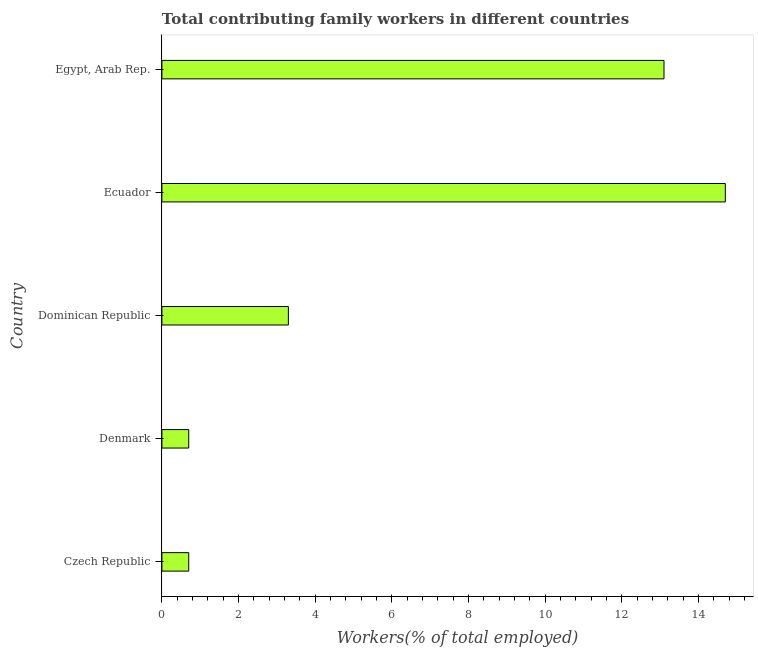Does the graph contain any zero values?
Keep it short and to the point. No. Does the graph contain grids?
Offer a terse response. No. What is the title of the graph?
Make the answer very short. Total contributing family workers in different countries. What is the label or title of the X-axis?
Make the answer very short. Workers(% of total employed). What is the contributing family workers in Dominican Republic?
Your answer should be very brief. 3.3. Across all countries, what is the maximum contributing family workers?
Offer a terse response. 14.7. Across all countries, what is the minimum contributing family workers?
Provide a succinct answer. 0.7. In which country was the contributing family workers maximum?
Offer a very short reply. Ecuador. In which country was the contributing family workers minimum?
Offer a very short reply. Czech Republic. What is the sum of the contributing family workers?
Offer a terse response. 32.5. What is the average contributing family workers per country?
Make the answer very short. 6.5. What is the median contributing family workers?
Give a very brief answer. 3.3. What is the ratio of the contributing family workers in Dominican Republic to that in Ecuador?
Offer a very short reply. 0.22. What is the difference between the highest and the second highest contributing family workers?
Your answer should be very brief. 1.6. In how many countries, is the contributing family workers greater than the average contributing family workers taken over all countries?
Ensure brevity in your answer.  2. How many bars are there?
Your response must be concise. 5. Are all the bars in the graph horizontal?
Provide a short and direct response. Yes. What is the difference between two consecutive major ticks on the X-axis?
Ensure brevity in your answer.  2. What is the Workers(% of total employed) in Czech Republic?
Offer a terse response. 0.7. What is the Workers(% of total employed) in Denmark?
Your answer should be very brief. 0.7. What is the Workers(% of total employed) in Dominican Republic?
Offer a very short reply. 3.3. What is the Workers(% of total employed) of Ecuador?
Ensure brevity in your answer.  14.7. What is the Workers(% of total employed) in Egypt, Arab Rep.?
Keep it short and to the point. 13.1. What is the difference between the Workers(% of total employed) in Czech Republic and Denmark?
Offer a very short reply. 0. What is the difference between the Workers(% of total employed) in Czech Republic and Egypt, Arab Rep.?
Provide a short and direct response. -12.4. What is the difference between the Workers(% of total employed) in Denmark and Ecuador?
Your answer should be very brief. -14. What is the difference between the Workers(% of total employed) in Dominican Republic and Ecuador?
Make the answer very short. -11.4. What is the difference between the Workers(% of total employed) in Ecuador and Egypt, Arab Rep.?
Your answer should be very brief. 1.6. What is the ratio of the Workers(% of total employed) in Czech Republic to that in Dominican Republic?
Keep it short and to the point. 0.21. What is the ratio of the Workers(% of total employed) in Czech Republic to that in Ecuador?
Provide a succinct answer. 0.05. What is the ratio of the Workers(% of total employed) in Czech Republic to that in Egypt, Arab Rep.?
Offer a very short reply. 0.05. What is the ratio of the Workers(% of total employed) in Denmark to that in Dominican Republic?
Your answer should be very brief. 0.21. What is the ratio of the Workers(% of total employed) in Denmark to that in Ecuador?
Offer a terse response. 0.05. What is the ratio of the Workers(% of total employed) in Denmark to that in Egypt, Arab Rep.?
Make the answer very short. 0.05. What is the ratio of the Workers(% of total employed) in Dominican Republic to that in Ecuador?
Provide a short and direct response. 0.22. What is the ratio of the Workers(% of total employed) in Dominican Republic to that in Egypt, Arab Rep.?
Your answer should be very brief. 0.25. What is the ratio of the Workers(% of total employed) in Ecuador to that in Egypt, Arab Rep.?
Your answer should be compact. 1.12. 